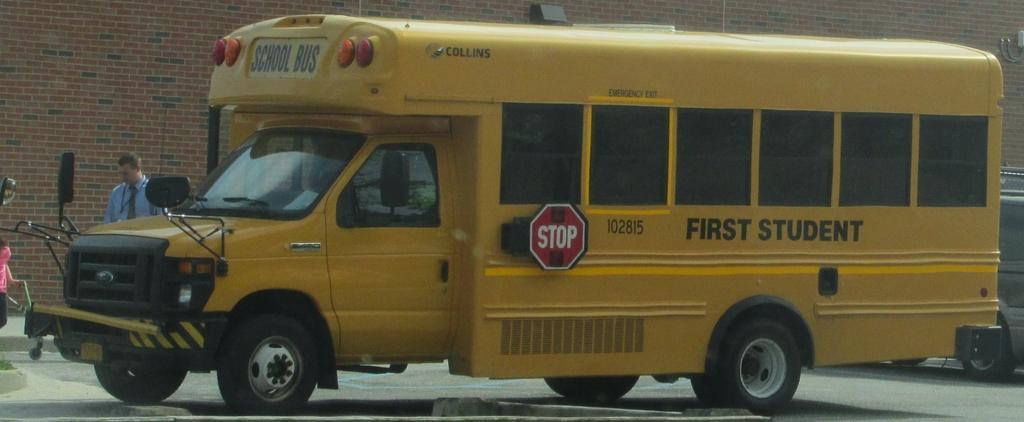Can you describe this image briefly? This image consists of a bus in yellow color. At the bottom, there is a road. On the left, we can see a man standing. In the background, there is a building. On the right, there is another vehicle. 